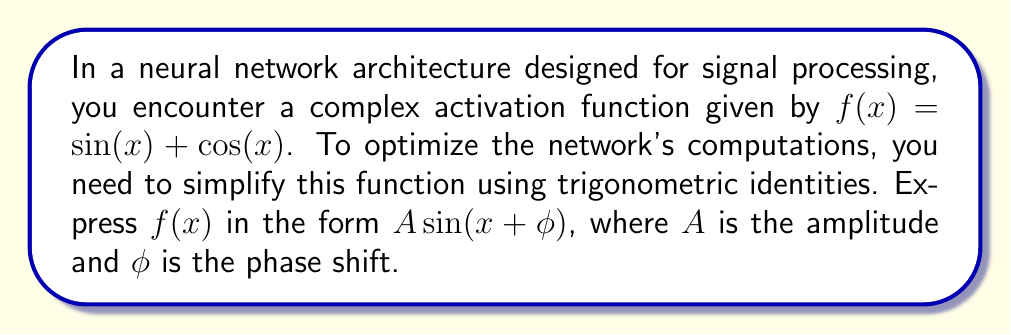Can you solve this math problem? Let's approach this step-by-step:

1) We start with the given function: $f(x) = \sin(x) + \cos(x)$

2) To simplify this, we can use the trigonometric identity for the sum of sine and cosine:

   $A \sin(x + \phi) = A \sin(x) \cos(\phi) + A \cos(x) \sin(\phi)$

3) Comparing our function with this identity, we can see that:
   
   $A \cos(\phi) = 1$ (coefficient of $\sin(x)$)
   $A \sin(\phi) = 1$ (coefficient of $\cos(x)$)

4) To find $A$, we can square and add these equations:

   $A^2 \cos^2(\phi) + A^2 \sin^2(\phi) = 1^2 + 1^2$

5) Using the identity $\cos^2(\phi) + \sin^2(\phi) = 1$, we get:

   $A^2(1) = 2$
   $A^2 = 2$
   $A = \sqrt{2}$

6) To find $\phi$, we can use the fact that $\tan(\phi) = \frac{\sin(\phi)}{\cos(\phi)}$:

   $\tan(\phi) = \frac{A \sin(\phi)}{A \cos(\phi)} = \frac{1}{1} = 1$

7) Therefore, $\phi = \arctan(1) = \frac{\pi}{4}$

8) Thus, we can express $f(x)$ as:

   $f(x) = \sqrt{2} \sin(x + \frac{\pi}{4})$

This simplified form can significantly reduce computational complexity in neural network operations, especially when dealing with large-scale signal processing tasks.
Answer: $\sqrt{2} \sin(x + \frac{\pi}{4})$ 